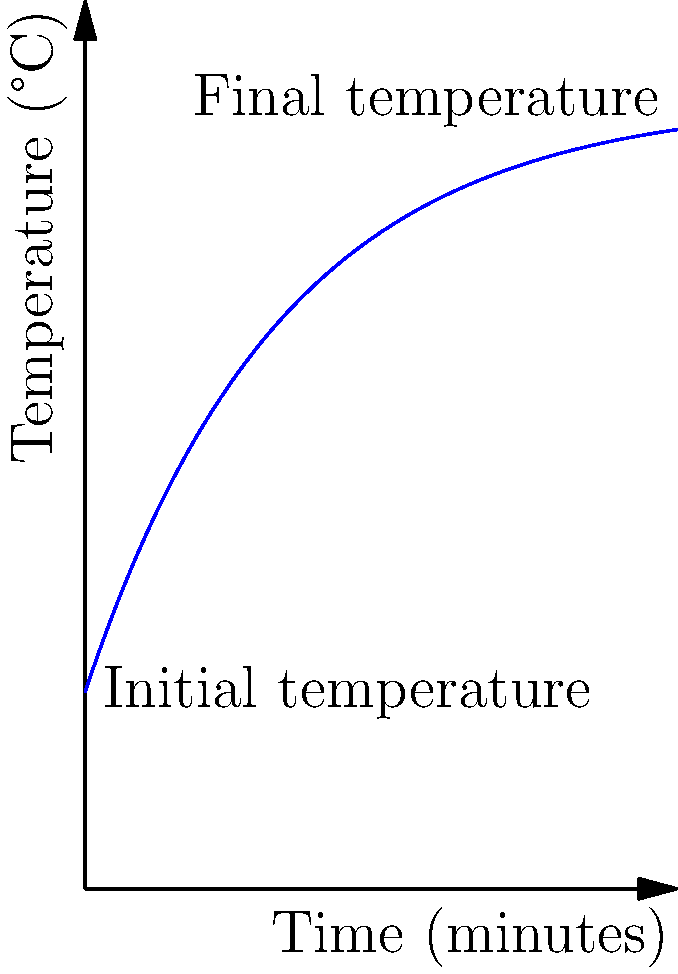In your skincare production facility, you're using a mixing vessel to create a new formulation. The vessel starts at room temperature (20°C) and needs to reach 80°C for optimal blending. The heating system follows an exponential heating curve as shown in the graph. If the time constant of the system is 20 minutes, how long will it take for the mixture to reach 70°C? To solve this problem, we'll use the exponential heating equation and the given information:

1. The heating equation is: $T(t) = T_f - (T_f - T_i)e^{-t/\tau}$
   Where:
   $T(t)$ is the temperature at time $t$
   $T_f$ is the final temperature (80°C)
   $T_i$ is the initial temperature (20°C)
   $\tau$ is the time constant (20 minutes)

2. We want to find $t$ when $T(t) = 70°C$. Let's substitute the known values:

   $70 = 80 - (80 - 20)e^{-t/20}$

3. Simplify:
   $70 = 80 - 60e^{-t/20}$

4. Subtract 80 from both sides:
   $-10 = -60e^{-t/20}$

5. Divide both sides by -60:
   $\frac{1}{6} = e^{-t/20}$

6. Take the natural log of both sides:
   $\ln(\frac{1}{6}) = -\frac{t}{20}$

7. Multiply both sides by -20:
   $-20\ln(\frac{1}{6}) = t$

8. Calculate the result:
   $t \approx 35.8$ minutes

Therefore, it will take approximately 35.8 minutes for the mixture to reach 70°C.
Answer: 35.8 minutes 